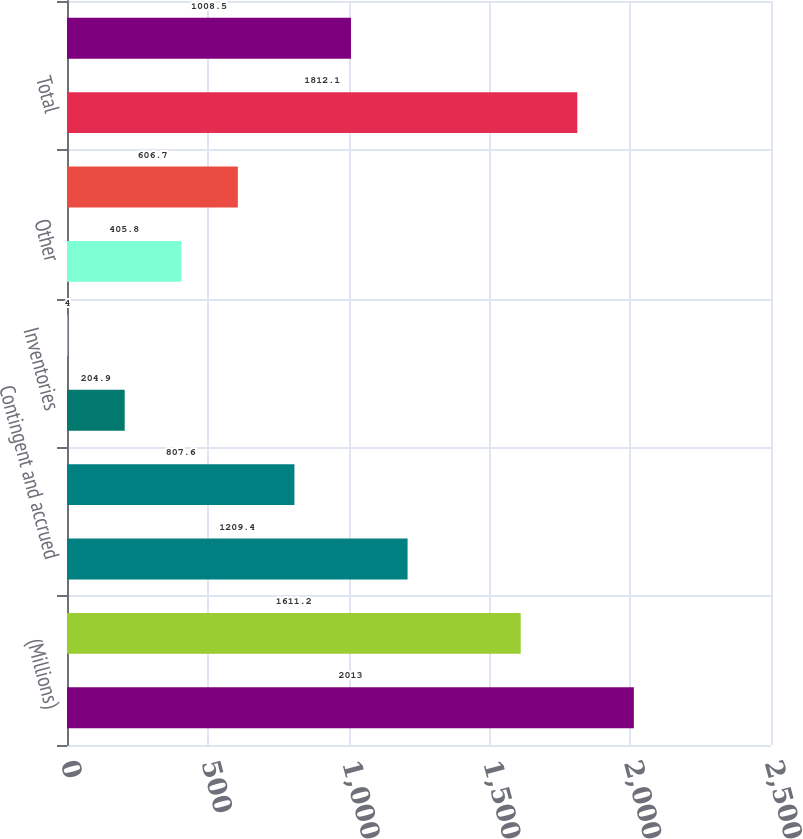Convert chart to OTSL. <chart><loc_0><loc_0><loc_500><loc_500><bar_chart><fcel>(Millions)<fcel>Employee benefits<fcel>Contingent and accrued<fcel>Operating loss and other<fcel>Inventories<fcel>Property<fcel>Other<fcel>Valuation allowance<fcel>Total<fcel>Intangibles<nl><fcel>2013<fcel>1611.2<fcel>1209.4<fcel>807.6<fcel>204.9<fcel>4<fcel>405.8<fcel>606.7<fcel>1812.1<fcel>1008.5<nl></chart> 